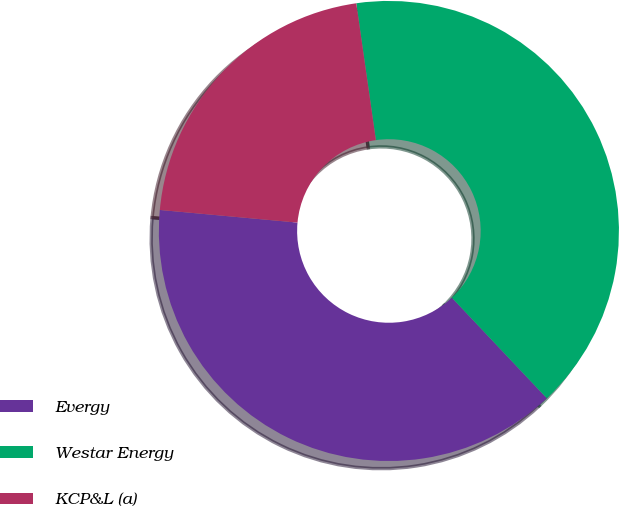<chart> <loc_0><loc_0><loc_500><loc_500><pie_chart><fcel>Evergy<fcel>Westar Energy<fcel>KCP&L (a)<nl><fcel>38.5%<fcel>40.22%<fcel>21.28%<nl></chart> 